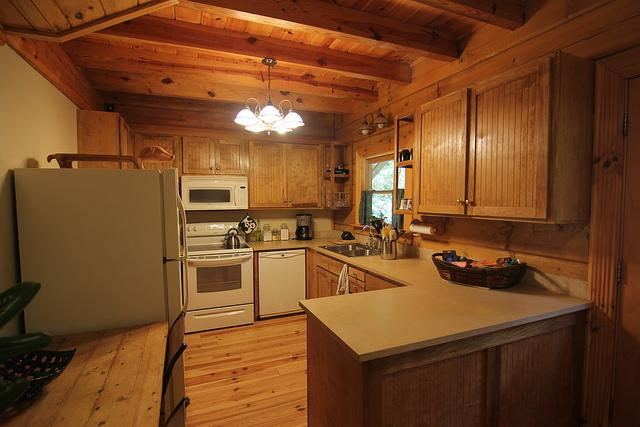What are the brightest lights attached to?

Choices:
A) arena entrance
B) ceiling
C) computer
D) car ceiling 